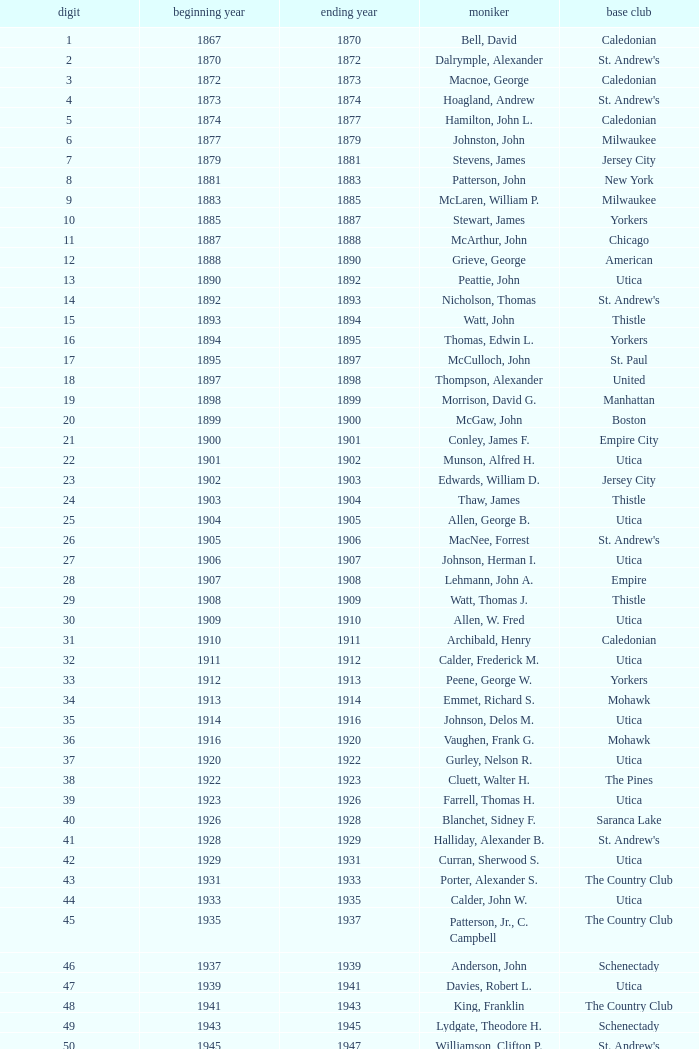Which Number has a Year Start smaller than 1874, and a Year End larger than 1873? 4.0. 